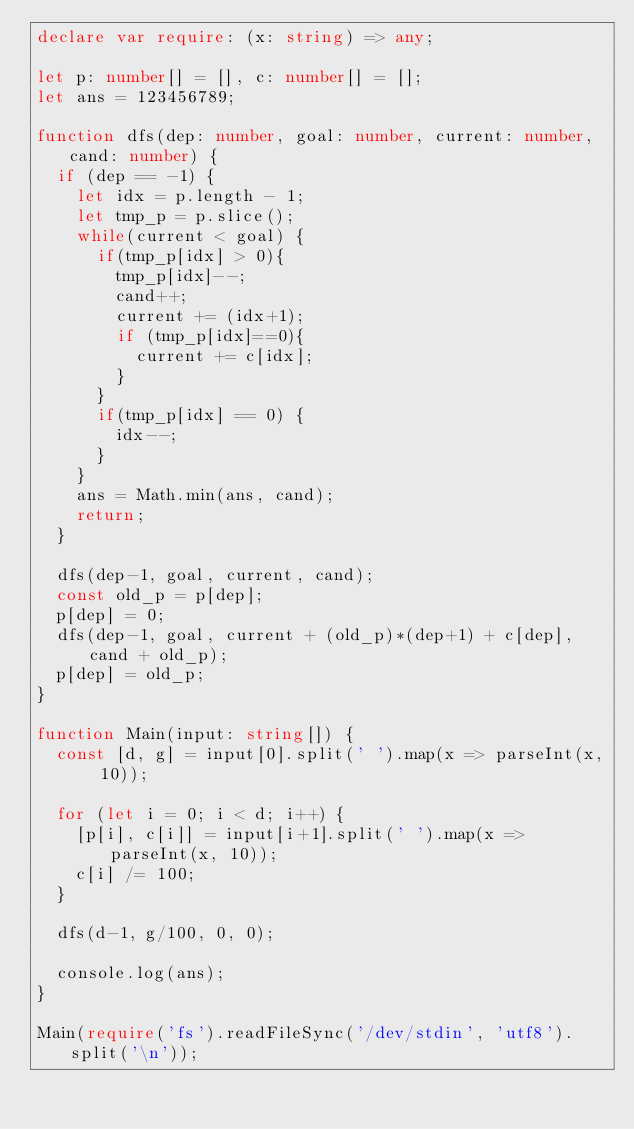Convert code to text. <code><loc_0><loc_0><loc_500><loc_500><_TypeScript_>declare var require: (x: string) => any;

let p: number[] = [], c: number[] = [];
let ans = 123456789;

function dfs(dep: number, goal: number, current: number, cand: number) {
  if (dep == -1) {
    let idx = p.length - 1;
    let tmp_p = p.slice();
    while(current < goal) {
      if(tmp_p[idx] > 0){
        tmp_p[idx]--;
        cand++;
        current += (idx+1);
        if (tmp_p[idx]==0){
          current += c[idx];
        }
      }
      if(tmp_p[idx] == 0) {
        idx--;
      }
    }
    ans = Math.min(ans, cand);
    return;
  }

  dfs(dep-1, goal, current, cand);
  const old_p = p[dep];
  p[dep] = 0;
  dfs(dep-1, goal, current + (old_p)*(dep+1) + c[dep], cand + old_p);
  p[dep] = old_p;
}

function Main(input: string[]) {
  const [d, g] = input[0].split(' ').map(x => parseInt(x, 10));

  for (let i = 0; i < d; i++) {
    [p[i], c[i]] = input[i+1].split(' ').map(x => parseInt(x, 10));
    c[i] /= 100;
  }

  dfs(d-1, g/100, 0, 0);

  console.log(ans);
}

Main(require('fs').readFileSync('/dev/stdin', 'utf8').split('\n'));
</code> 